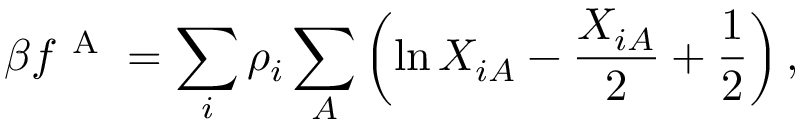<formula> <loc_0><loc_0><loc_500><loc_500>\beta f ^ { A } = \sum _ { i } \rho _ { i } \sum _ { A } \left ( \ln X _ { i A } - \frac { X _ { i A } } { 2 } + \frac { 1 } { 2 } \right ) ,</formula> 